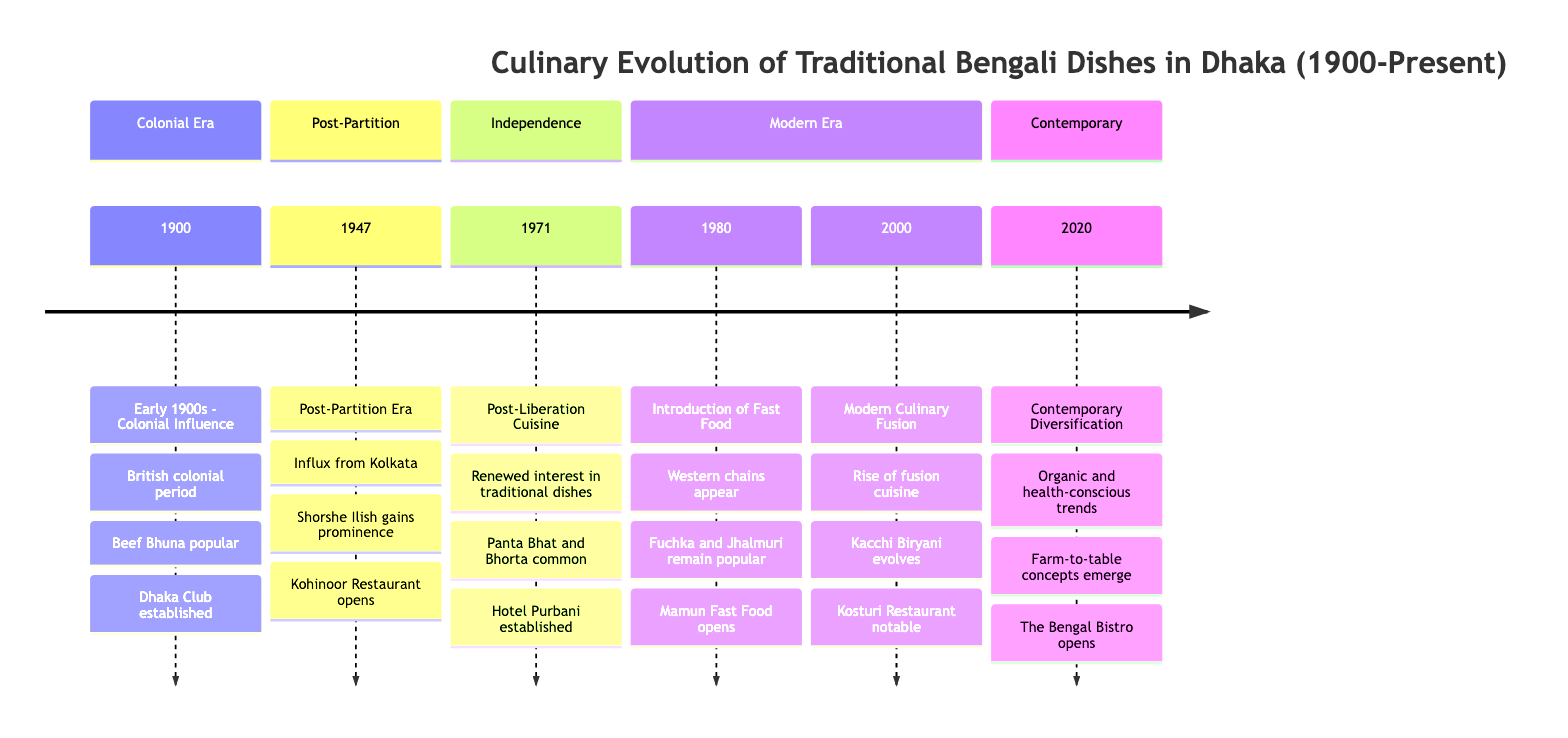What year marks the Colonial Influence in Dhaka's culinary history? The diagram indicates that the year 1900 marks the beginning of the Colonial Influence in Dhaka's culinary scene.
Answer: 1900 What dish became popular during the Colonial period in affluent households? According to the information in the diagram, Beef Bhuna became a popular dish during the Colonial period in affluent households in Dhaka.
Answer: Beef Bhuna Which restaurant opened in 1947 during the Post-Partition Era? The timeline shows that Kohinoor Restaurant opened in the year 1947, coinciding with the Post-Partition Era when many Kolkata culinary traditions arrived in Dhaka.
Answer: Kohinoor Restaurant What significant culinary trend began in 2020? In 2020, the culinary trend of Contemporary Diversification began, focusing on organic and health-conscious adaptations of Bengali dishes.
Answer: Contemporary Diversification How many notable restaurants are mentioned in the timeline? The timeline lists five notable restaurants: Dhaka Club, Kohinoor Restaurant, Hotel Purbani, Mamun Fast Food, and Kosturi Restaurant. Therefore, there are five notable restaurants in total.
Answer: 5 Which year corresponds to the introduction of fast food in Dhaka? The timeline specifies that the introduction of fast food occurred in the year 1980, where it notes the appearance of Western fast food chains.
Answer: 1980 What dish gained prominence in Dhaka after the 1947 Partition? After the 1947 Partition, Shorshe Ilish, which is Hilsa fish in mustard sauce, gained prominence in Dhaka's culinary offerings.
Answer: Shorshe Ilish Which restaurant is associated with the Modern Culinary Fusion trend? The timeline states that Kosturi Restaurant is noted for its association with the trend of Modern Culinary Fusion that began around the year 2000.
Answer: Kosturi Restaurant What culinary influence did people from Kolkata bring to Dhaka in 1947? The diagram indicates that people from Kolkata brought their culinary traditions, especially notable dishes like Shorshe Ilish, to Dhaka in 1947.
Answer: Kolkata culinary traditions 